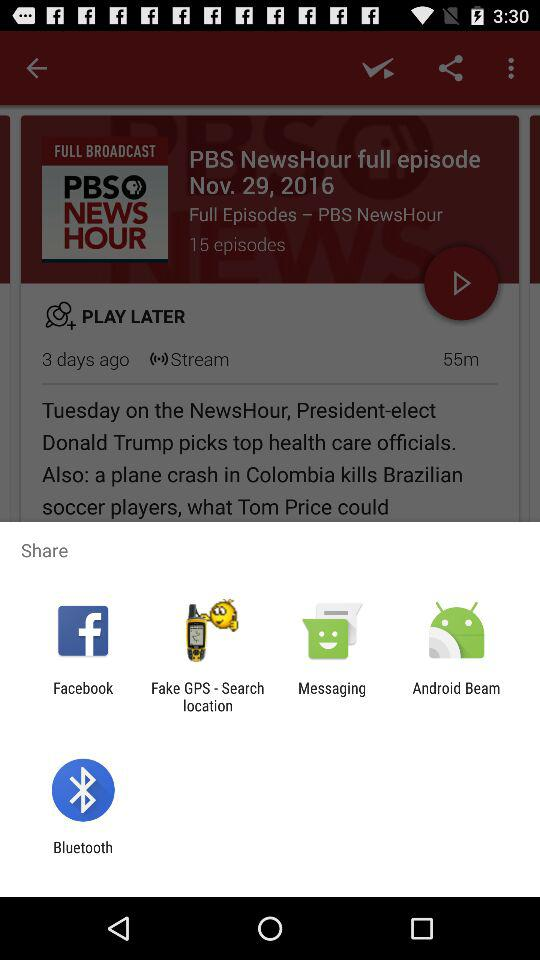What are the different options available for sharing? The different options available for sharing are "Facebook", "Fake GPS - Search location", "Messaging", "Android Beam" and "Bluetooth". 